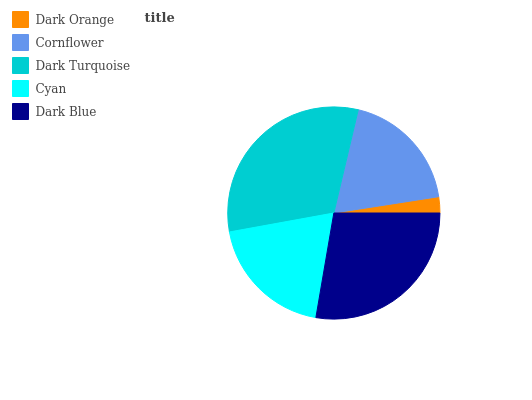Is Dark Orange the minimum?
Answer yes or no. Yes. Is Dark Turquoise the maximum?
Answer yes or no. Yes. Is Cornflower the minimum?
Answer yes or no. No. Is Cornflower the maximum?
Answer yes or no. No. Is Cornflower greater than Dark Orange?
Answer yes or no. Yes. Is Dark Orange less than Cornflower?
Answer yes or no. Yes. Is Dark Orange greater than Cornflower?
Answer yes or no. No. Is Cornflower less than Dark Orange?
Answer yes or no. No. Is Cyan the high median?
Answer yes or no. Yes. Is Cyan the low median?
Answer yes or no. Yes. Is Dark Orange the high median?
Answer yes or no. No. Is Dark Orange the low median?
Answer yes or no. No. 